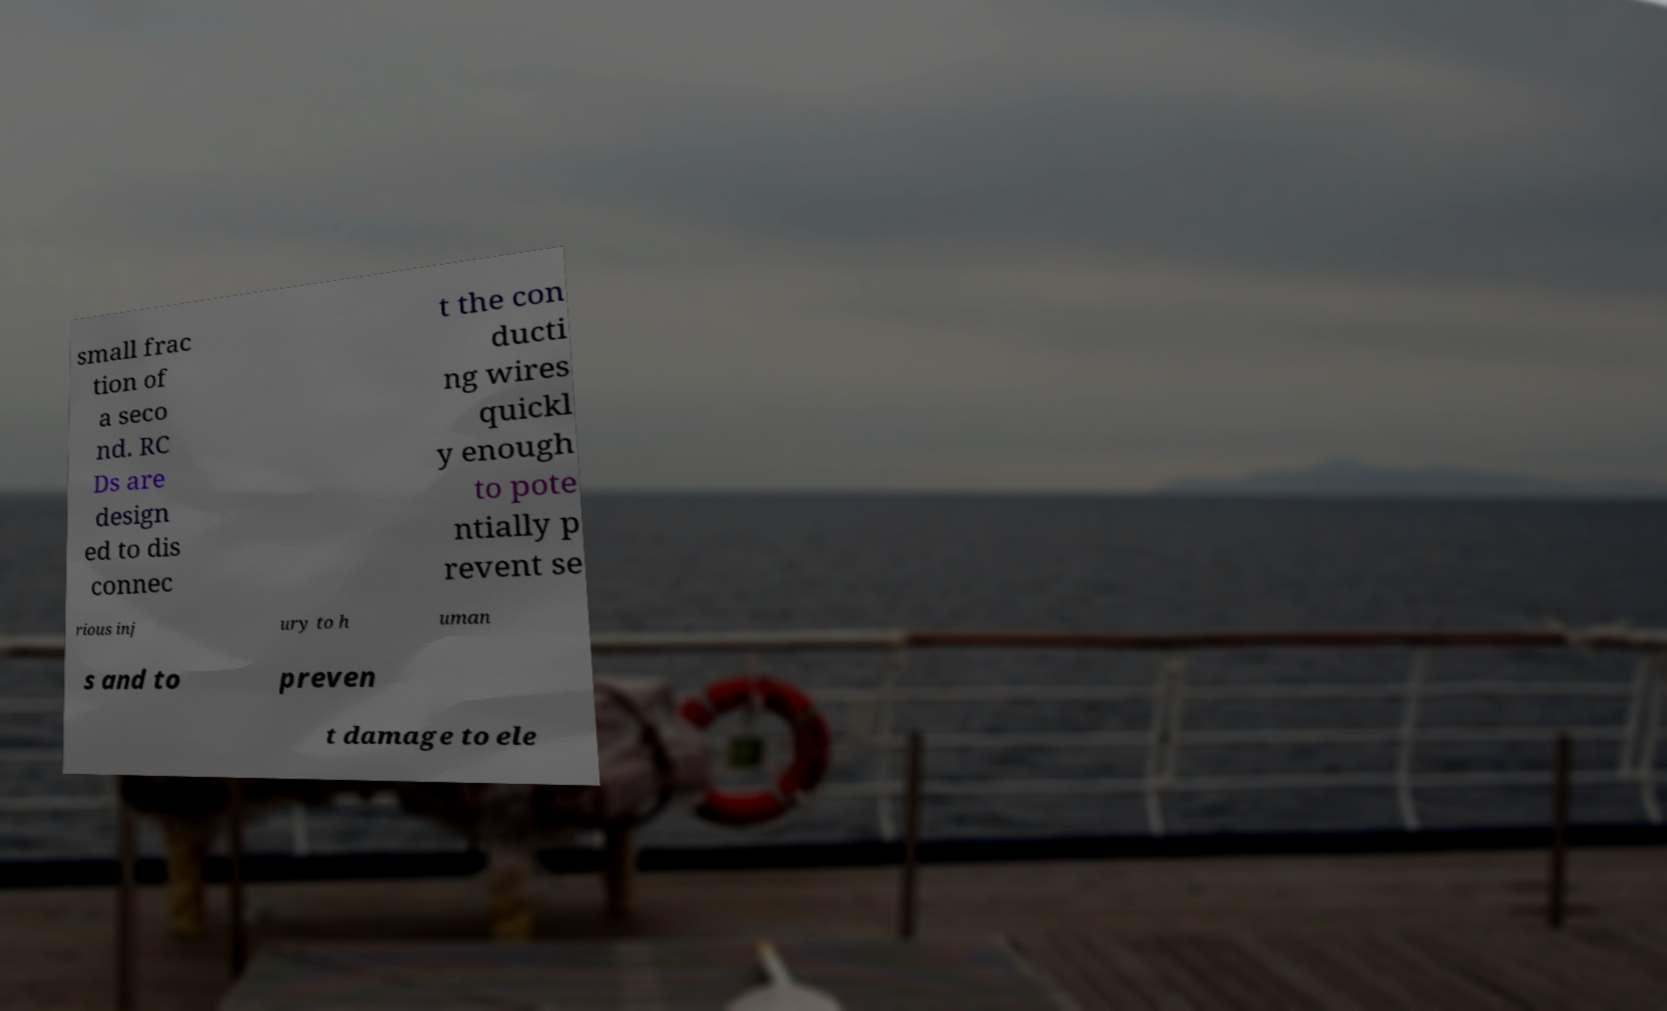I need the written content from this picture converted into text. Can you do that? small frac tion of a seco nd. RC Ds are design ed to dis connec t the con ducti ng wires quickl y enough to pote ntially p revent se rious inj ury to h uman s and to preven t damage to ele 